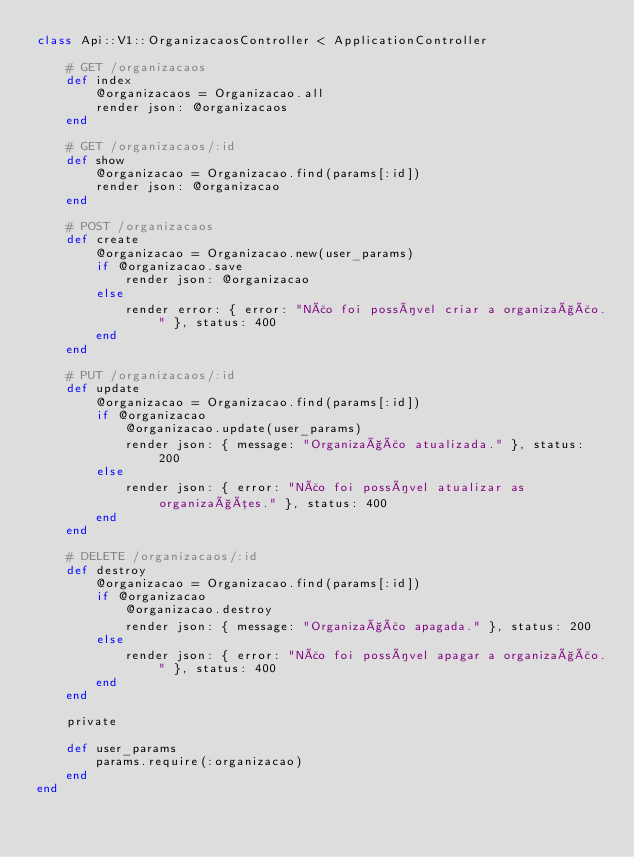<code> <loc_0><loc_0><loc_500><loc_500><_Ruby_>class Api::V1::OrganizacaosController < ApplicationController

	# GET /organizacaos
	def index
		@organizacaos = Organizacao.all
		render json: @organizacaos
	end

	# GET /organizacaos/:id
	def show
		@organizacao = Organizacao.find(params[:id])
		render json: @organizacao
	end

	# POST /organizacaos
	def create
		@organizacao = Organizacao.new(user_params)
		if @organizacao.save
			render json: @organizacao
		else
			render error: { error: "Não foi possível criar a organização." }, status: 400
		end
	end

	# PUT /organizacaos/:id
	def update
		@organizacao = Organizacao.find(params[:id])
		if @organizacao
			@organizacao.update(user_params)
			render json: { message: "Organização atualizada." }, status: 200
		else
			render json: { error: "Não foi possível atualizar as organizações." }, status: 400
		end
	end

	# DELETE /organizacaos/:id
	def destroy
		@organizacao = Organizacao.find(params[:id])
		if @organizacao
			@organizacao.destroy
			render json: { message: "Organização apagada." }, status: 200
		else
			render json: { error: "Não foi possível apagar a organização." }, status: 400
		end
	end

	private

	def user_params
		params.require(:organizacao)
	end
end
</code> 